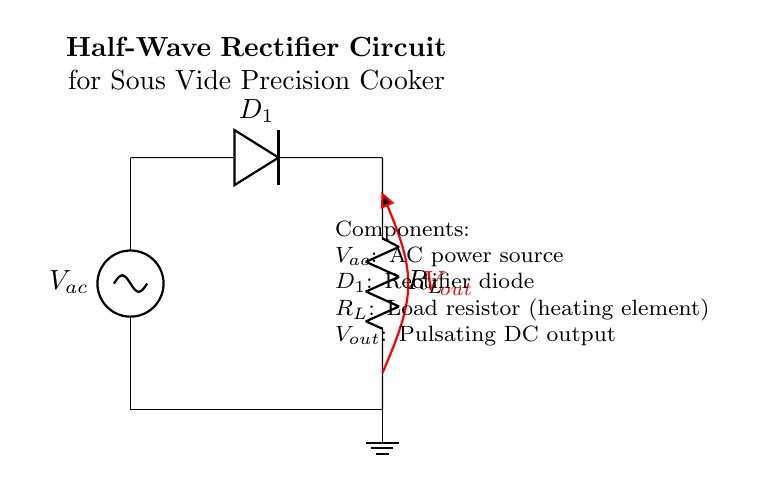What is the type of circuit shown? The circuit diagram depicts a half-wave rectifier, which is designed to convert alternating current to direct current. The presence of a diode and a single load resistor indicates a half-wave rectification configuration.
Answer: half-wave rectifier What component is used for rectification? The diagram features a single diode labeled D1, which allows current to flow in one direction, effectively converting AC to DC during the positive half of the waveform while blocking negative current.
Answer: diode What is the role of the load resistor? The load resistor, labeled R_L, is where the output DC power is delivered and is typically used to generate heat in the cooking process of a sous vide cooker. Its function is to dissipate power and manage the heating element's current.
Answer: heating element What is the output of the circuit? The output voltage, labeled V_out, is provided across the load resistor R_L. This output will be a pulsating DC voltage that occurs only during the positive cycle of the AC input.
Answer: pulsating DC What is the voltage source in the circuit? The AC power source is labeled V_ac. It supplies the alternating current needed to be rectified by the diode into a usable form for the heating element.
Answer: AC power source When does the diode conduct? The diode D1 conducts during the positive half-cycle of the AC input voltage, allowing current to pass and charge the load resistor while blocking current during the negative half-cycle.
Answer: positive half-cycle What would happen if the diode is reversed? If the diode is reversed, it would block current during both halves of the AC cycle, preventing any power from reaching the load resistor and rendering the circuit non-functional for cooking applications.
Answer: no power 